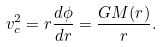Convert formula to latex. <formula><loc_0><loc_0><loc_500><loc_500>v _ { c } ^ { 2 } = r \frac { d \phi } { d r } = \frac { G M ( r ) } { r } .</formula> 